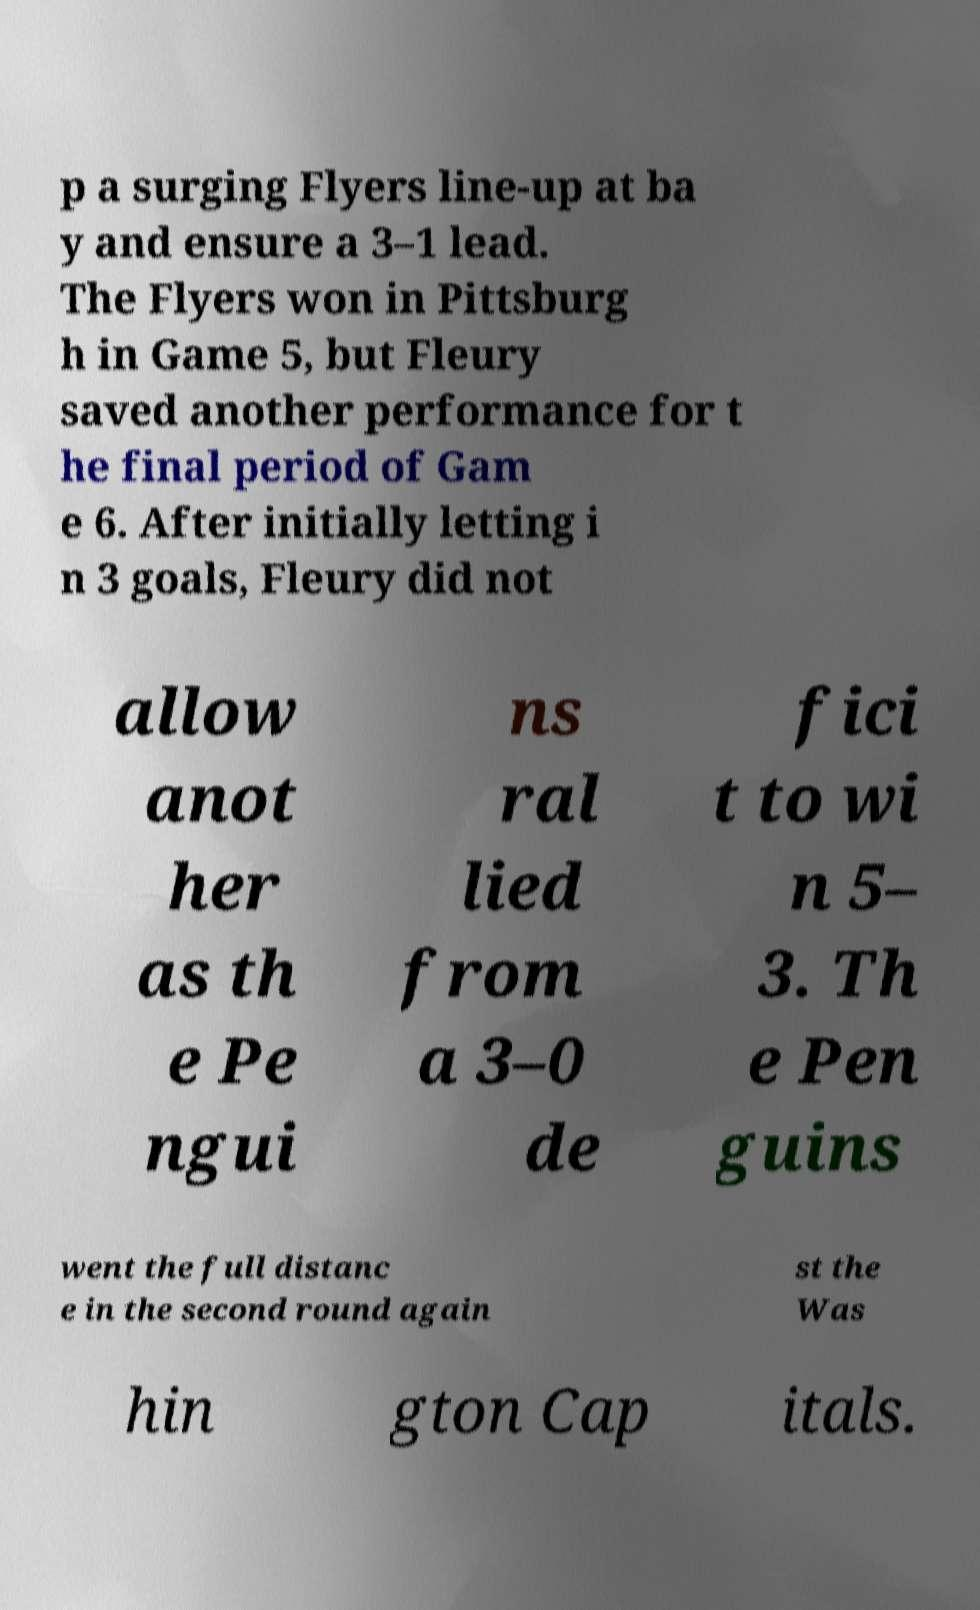Please read and relay the text visible in this image. What does it say? p a surging Flyers line-up at ba y and ensure a 3–1 lead. The Flyers won in Pittsburg h in Game 5, but Fleury saved another performance for t he final period of Gam e 6. After initially letting i n 3 goals, Fleury did not allow anot her as th e Pe ngui ns ral lied from a 3–0 de fici t to wi n 5– 3. Th e Pen guins went the full distanc e in the second round again st the Was hin gton Cap itals. 